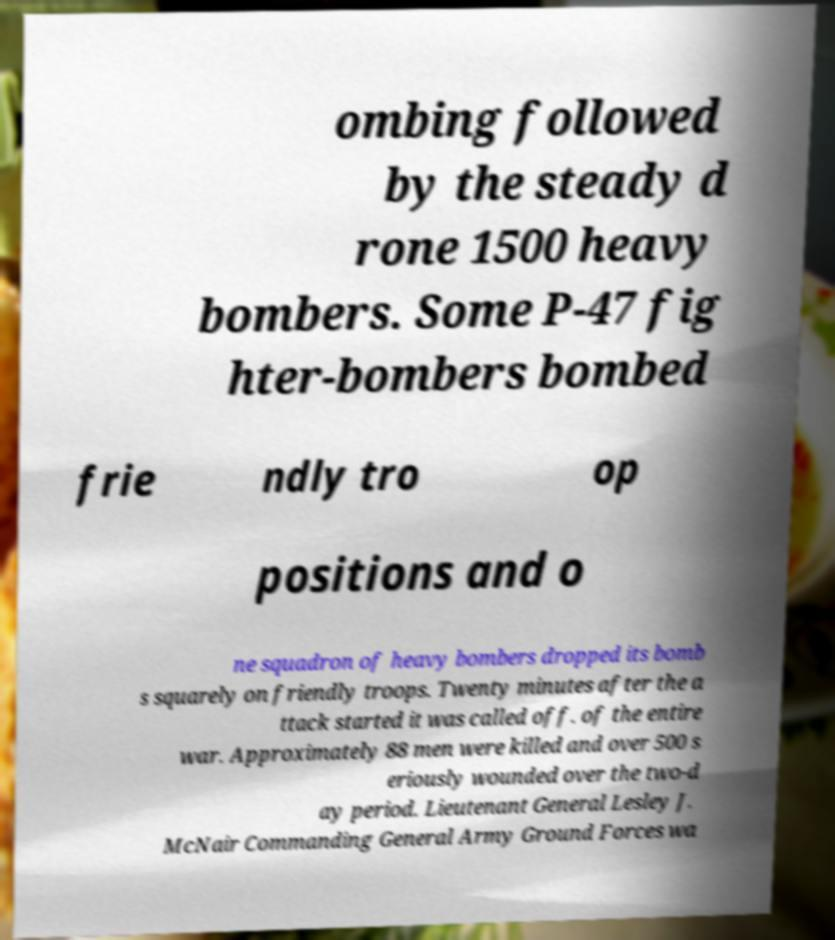What messages or text are displayed in this image? I need them in a readable, typed format. ombing followed by the steady d rone 1500 heavy bombers. Some P-47 fig hter-bombers bombed frie ndly tro op positions and o ne squadron of heavy bombers dropped its bomb s squarely on friendly troops. Twenty minutes after the a ttack started it was called off. of the entire war. Approximately 88 men were killed and over 500 s eriously wounded over the two-d ay period. Lieutenant General Lesley J. McNair Commanding General Army Ground Forces wa 